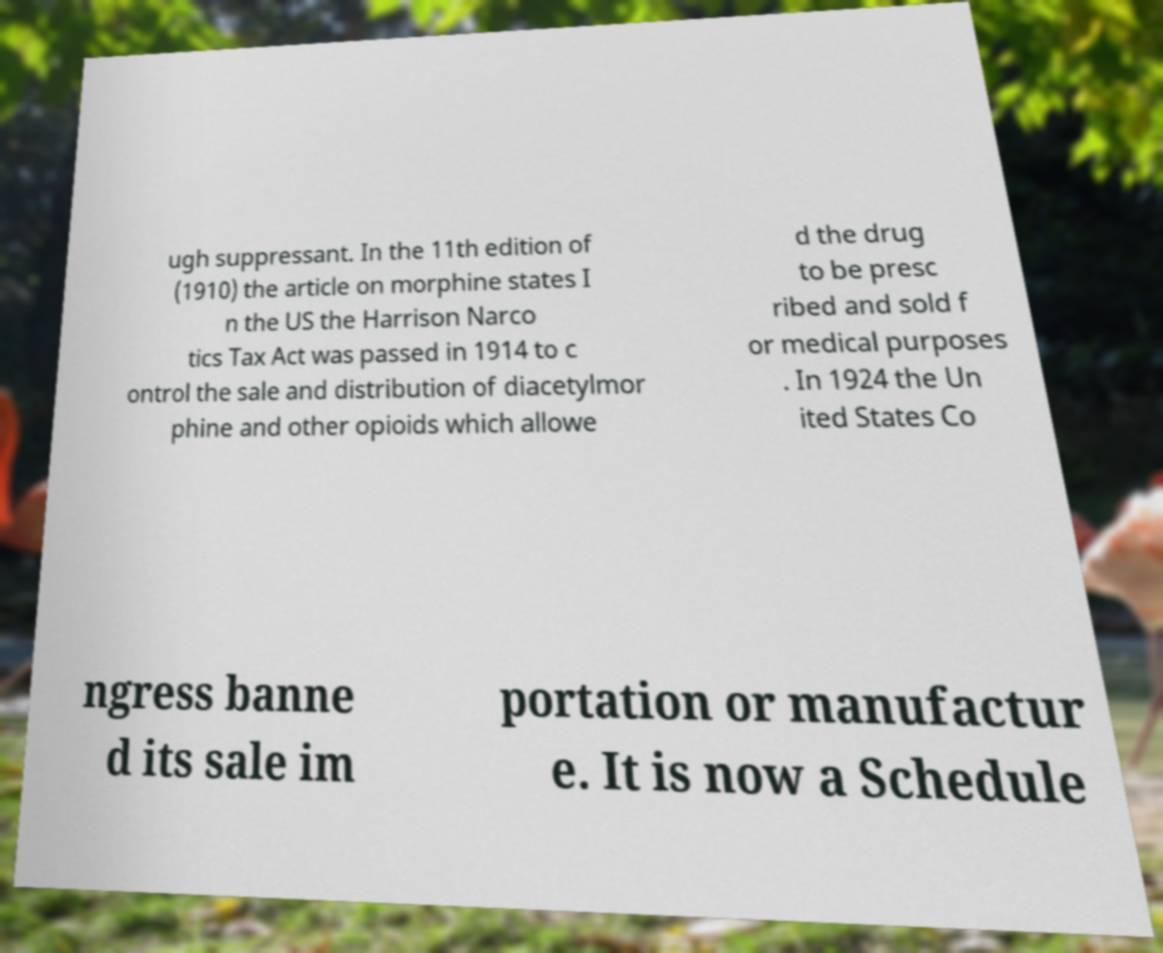There's text embedded in this image that I need extracted. Can you transcribe it verbatim? ugh suppressant. In the 11th edition of (1910) the article on morphine states I n the US the Harrison Narco tics Tax Act was passed in 1914 to c ontrol the sale and distribution of diacetylmor phine and other opioids which allowe d the drug to be presc ribed and sold f or medical purposes . In 1924 the Un ited States Co ngress banne d its sale im portation or manufactur e. It is now a Schedule 